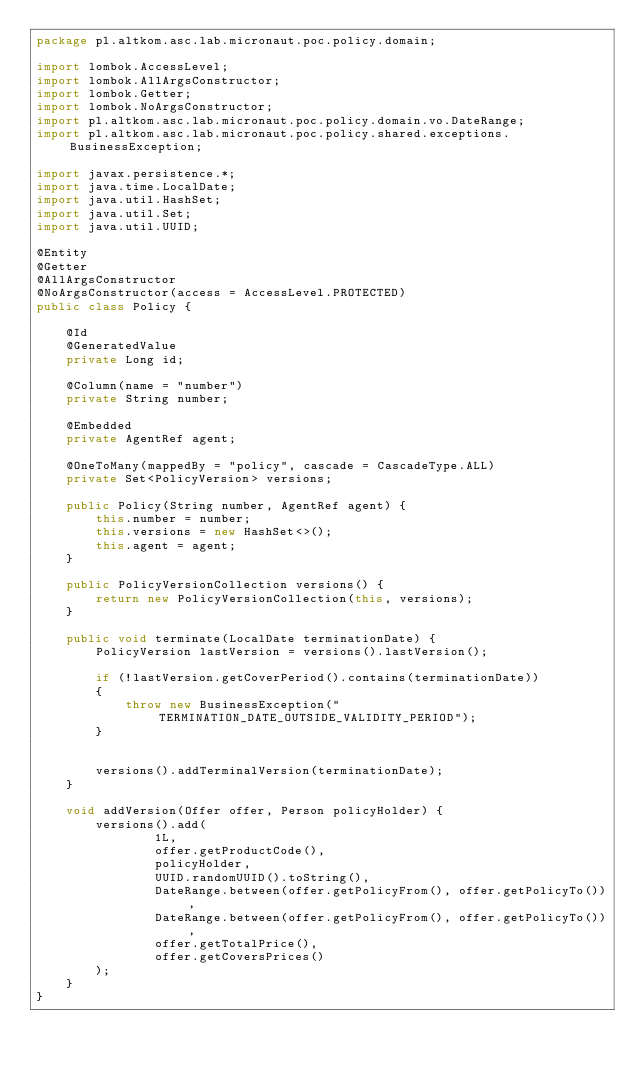Convert code to text. <code><loc_0><loc_0><loc_500><loc_500><_Java_>package pl.altkom.asc.lab.micronaut.poc.policy.domain;

import lombok.AccessLevel;
import lombok.AllArgsConstructor;
import lombok.Getter;
import lombok.NoArgsConstructor;
import pl.altkom.asc.lab.micronaut.poc.policy.domain.vo.DateRange;
import pl.altkom.asc.lab.micronaut.poc.policy.shared.exceptions.BusinessException;

import javax.persistence.*;
import java.time.LocalDate;
import java.util.HashSet;
import java.util.Set;
import java.util.UUID;

@Entity
@Getter
@AllArgsConstructor
@NoArgsConstructor(access = AccessLevel.PROTECTED)
public class Policy {

    @Id
    @GeneratedValue
    private Long id;

    @Column(name = "number")
    private String number;

    @Embedded
    private AgentRef agent;

    @OneToMany(mappedBy = "policy", cascade = CascadeType.ALL)
    private Set<PolicyVersion> versions;

    public Policy(String number, AgentRef agent) {
        this.number = number;
        this.versions = new HashSet<>();
        this.agent = agent;
    }

    public PolicyVersionCollection versions() {
        return new PolicyVersionCollection(this, versions);
    }

    public void terminate(LocalDate terminationDate) {
        PolicyVersion lastVersion = versions().lastVersion();

        if (!lastVersion.getCoverPeriod().contains(terminationDate))
        {
            throw new BusinessException("TERMINATION_DATE_OUTSIDE_VALIDITY_PERIOD");
        }


        versions().addTerminalVersion(terminationDate);
    }

    void addVersion(Offer offer, Person policyHolder) {
        versions().add(
                1L,
                offer.getProductCode(),
                policyHolder,
                UUID.randomUUID().toString(),
                DateRange.between(offer.getPolicyFrom(), offer.getPolicyTo()),
                DateRange.between(offer.getPolicyFrom(), offer.getPolicyTo()),
                offer.getTotalPrice(),
                offer.getCoversPrices()
        );
    }
}
</code> 